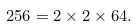Convert formula to latex. <formula><loc_0><loc_0><loc_500><loc_500>2 5 6 = 2 \times 2 \times 6 4 .</formula> 